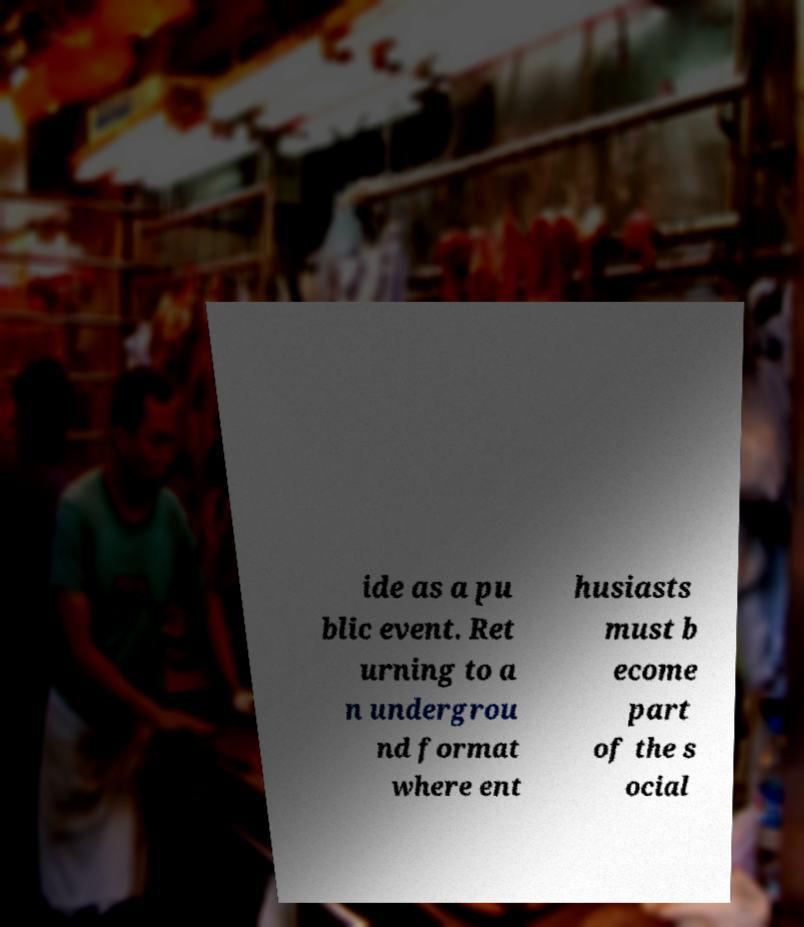Please read and relay the text visible in this image. What does it say? ide as a pu blic event. Ret urning to a n undergrou nd format where ent husiasts must b ecome part of the s ocial 